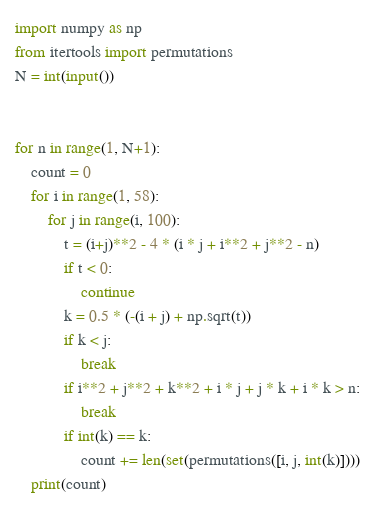<code> <loc_0><loc_0><loc_500><loc_500><_Python_>import numpy as np
from itertools import permutations
N = int(input())


for n in range(1, N+1):
    count = 0
    for i in range(1, 58):
        for j in range(i, 100):
            t = (i+j)**2 - 4 * (i * j + i**2 + j**2 - n)
            if t < 0:
                continue
            k = 0.5 * (-(i + j) + np.sqrt(t))
            if k < j:
                break
            if i**2 + j**2 + k**2 + i * j + j * k + i * k > n:
                break
            if int(k) == k:
                count += len(set(permutations([i, j, int(k)])))
    print(count)

</code> 